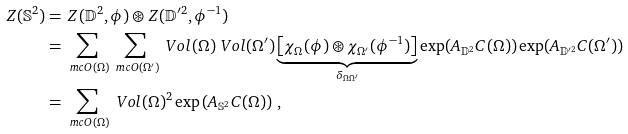<formula> <loc_0><loc_0><loc_500><loc_500>Z ( \mathbb { S } ^ { 2 } ) & = \, Z ( \mathbb { D } ^ { 2 } , \phi ) \circledast Z ( \mathbb { D } ^ { \prime 2 } , \phi ^ { - 1 } ) \\ & = \sum _ { \ m c { O } ( \Omega ) } \sum _ { \ m c { O } ( \Omega ^ { \prime } ) } \ V o l ( \Omega ) \ V o l ( \Omega ^ { \prime } ) \underbrace { \left [ \chi _ { \Omega } ( \phi ) \circledast \chi _ { \Omega ^ { \prime } } ( \phi ^ { - 1 } ) \right ] } _ { \delta _ { \Omega \Omega ^ { \prime } } } \exp ( A _ { \mathbb { D } ^ { 2 } } C ( \Omega ) ) \exp ( A _ { \mathbb { D } ^ { \prime 2 } } C ( \Omega ^ { \prime } ) ) \\ & = \sum _ { \ m c { O } ( \Omega ) } { \ V o l } ( \Omega ) ^ { 2 } \exp \left ( A _ { \mathbb { S } ^ { 2 } } C ( \Omega ) \right ) \, ,</formula> 